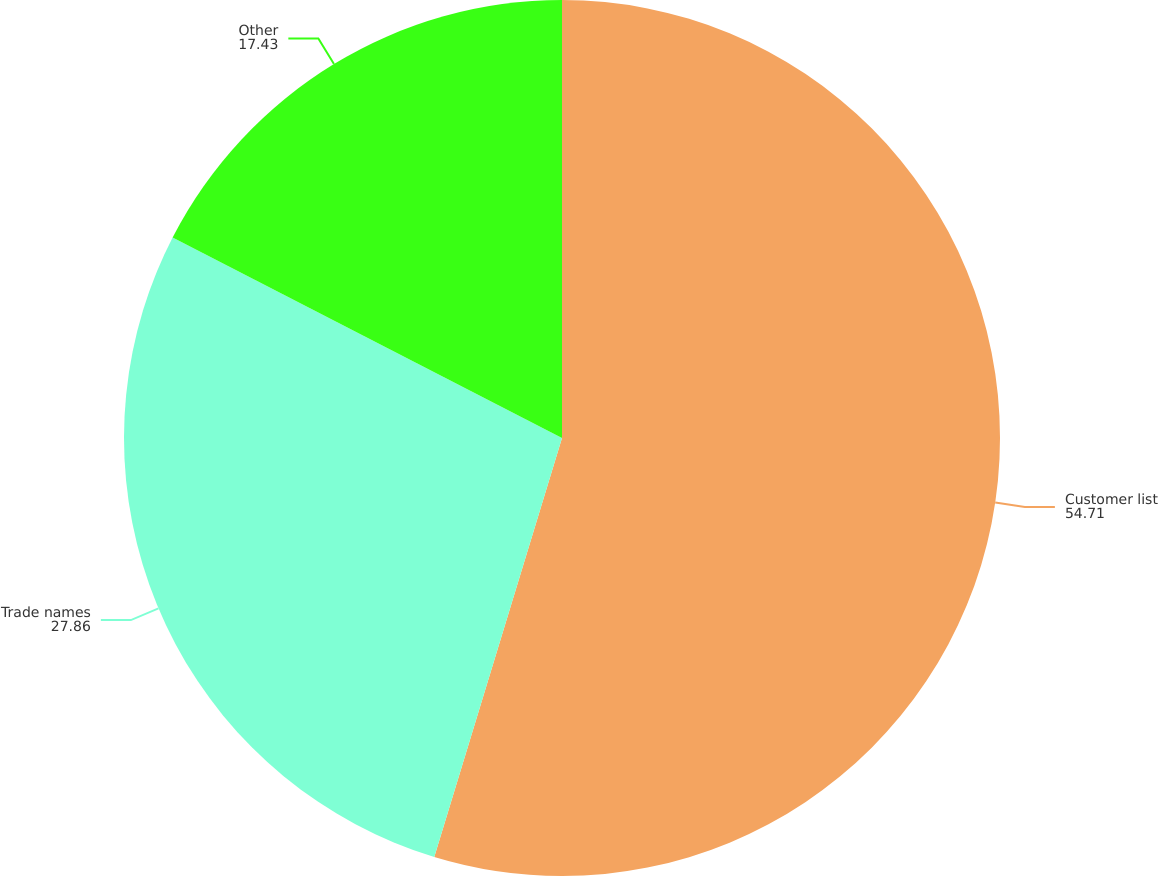Convert chart. <chart><loc_0><loc_0><loc_500><loc_500><pie_chart><fcel>Customer list<fcel>Trade names<fcel>Other<nl><fcel>54.71%<fcel>27.86%<fcel>17.43%<nl></chart> 